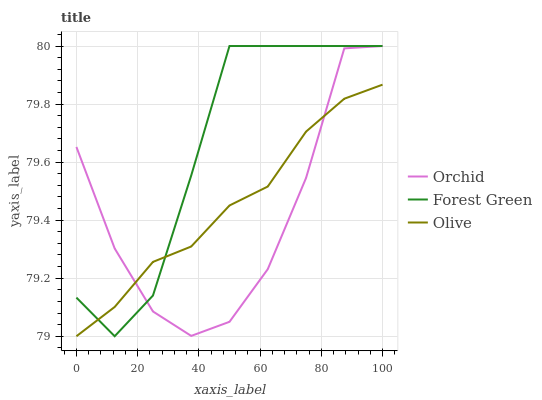Does Orchid have the minimum area under the curve?
Answer yes or no. Yes. Does Forest Green have the maximum area under the curve?
Answer yes or no. Yes. Does Forest Green have the minimum area under the curve?
Answer yes or no. No. Does Orchid have the maximum area under the curve?
Answer yes or no. No. Is Olive the smoothest?
Answer yes or no. Yes. Is Orchid the roughest?
Answer yes or no. Yes. Is Forest Green the smoothest?
Answer yes or no. No. Is Forest Green the roughest?
Answer yes or no. No. Does Olive have the lowest value?
Answer yes or no. Yes. Does Forest Green have the lowest value?
Answer yes or no. No. Does Orchid have the highest value?
Answer yes or no. Yes. Does Olive intersect Forest Green?
Answer yes or no. Yes. Is Olive less than Forest Green?
Answer yes or no. No. Is Olive greater than Forest Green?
Answer yes or no. No. 